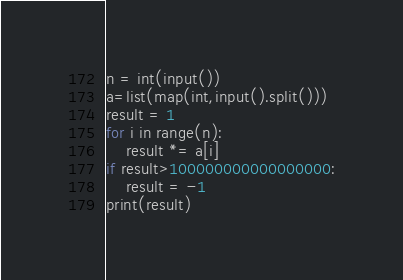<code> <loc_0><loc_0><loc_500><loc_500><_Python_>n = int(input())
a=list(map(int,input().split()))
result = 1
for i in range(n):
    result *= a[i]
if result>100000000000000000:
    result = -1
print(result)
</code> 